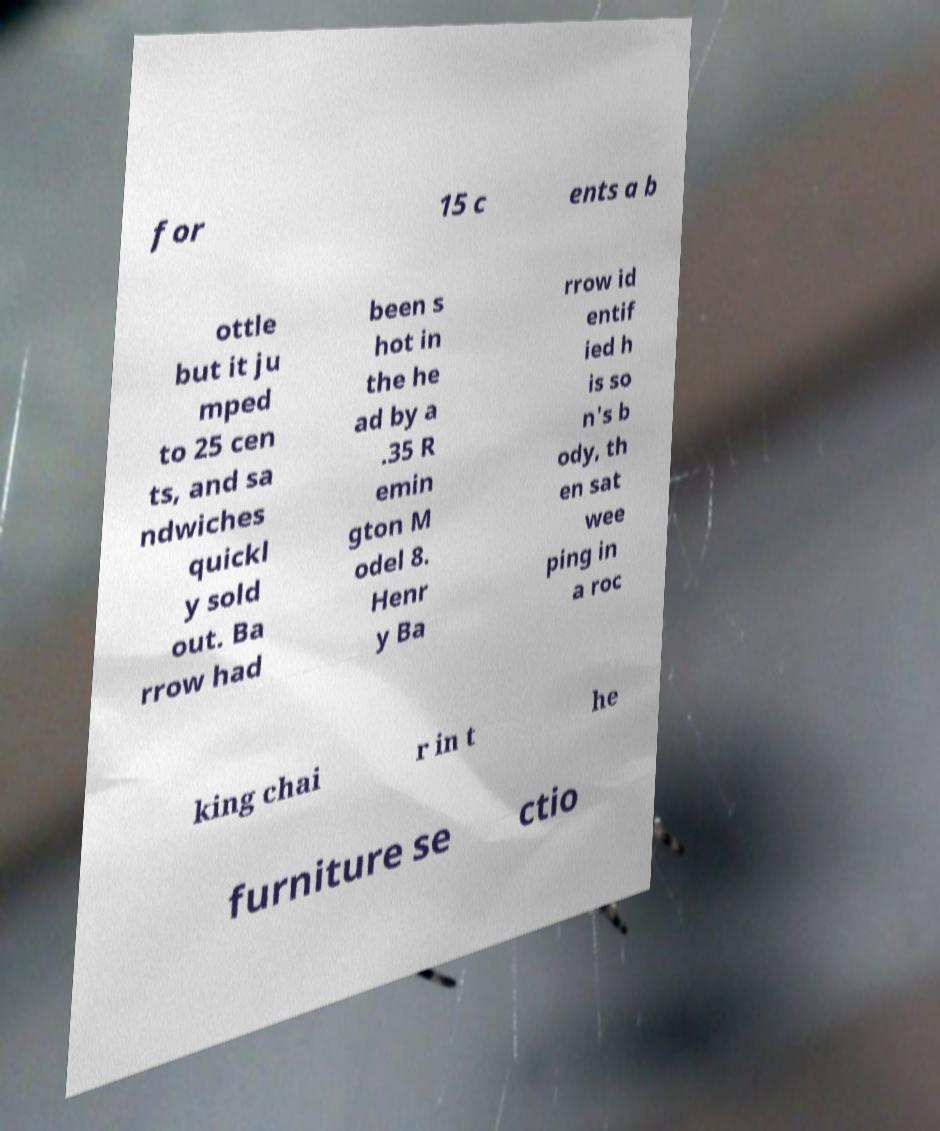Could you extract and type out the text from this image? for 15 c ents a b ottle but it ju mped to 25 cen ts, and sa ndwiches quickl y sold out. Ba rrow had been s hot in the he ad by a .35 R emin gton M odel 8. Henr y Ba rrow id entif ied h is so n's b ody, th en sat wee ping in a roc king chai r in t he furniture se ctio 